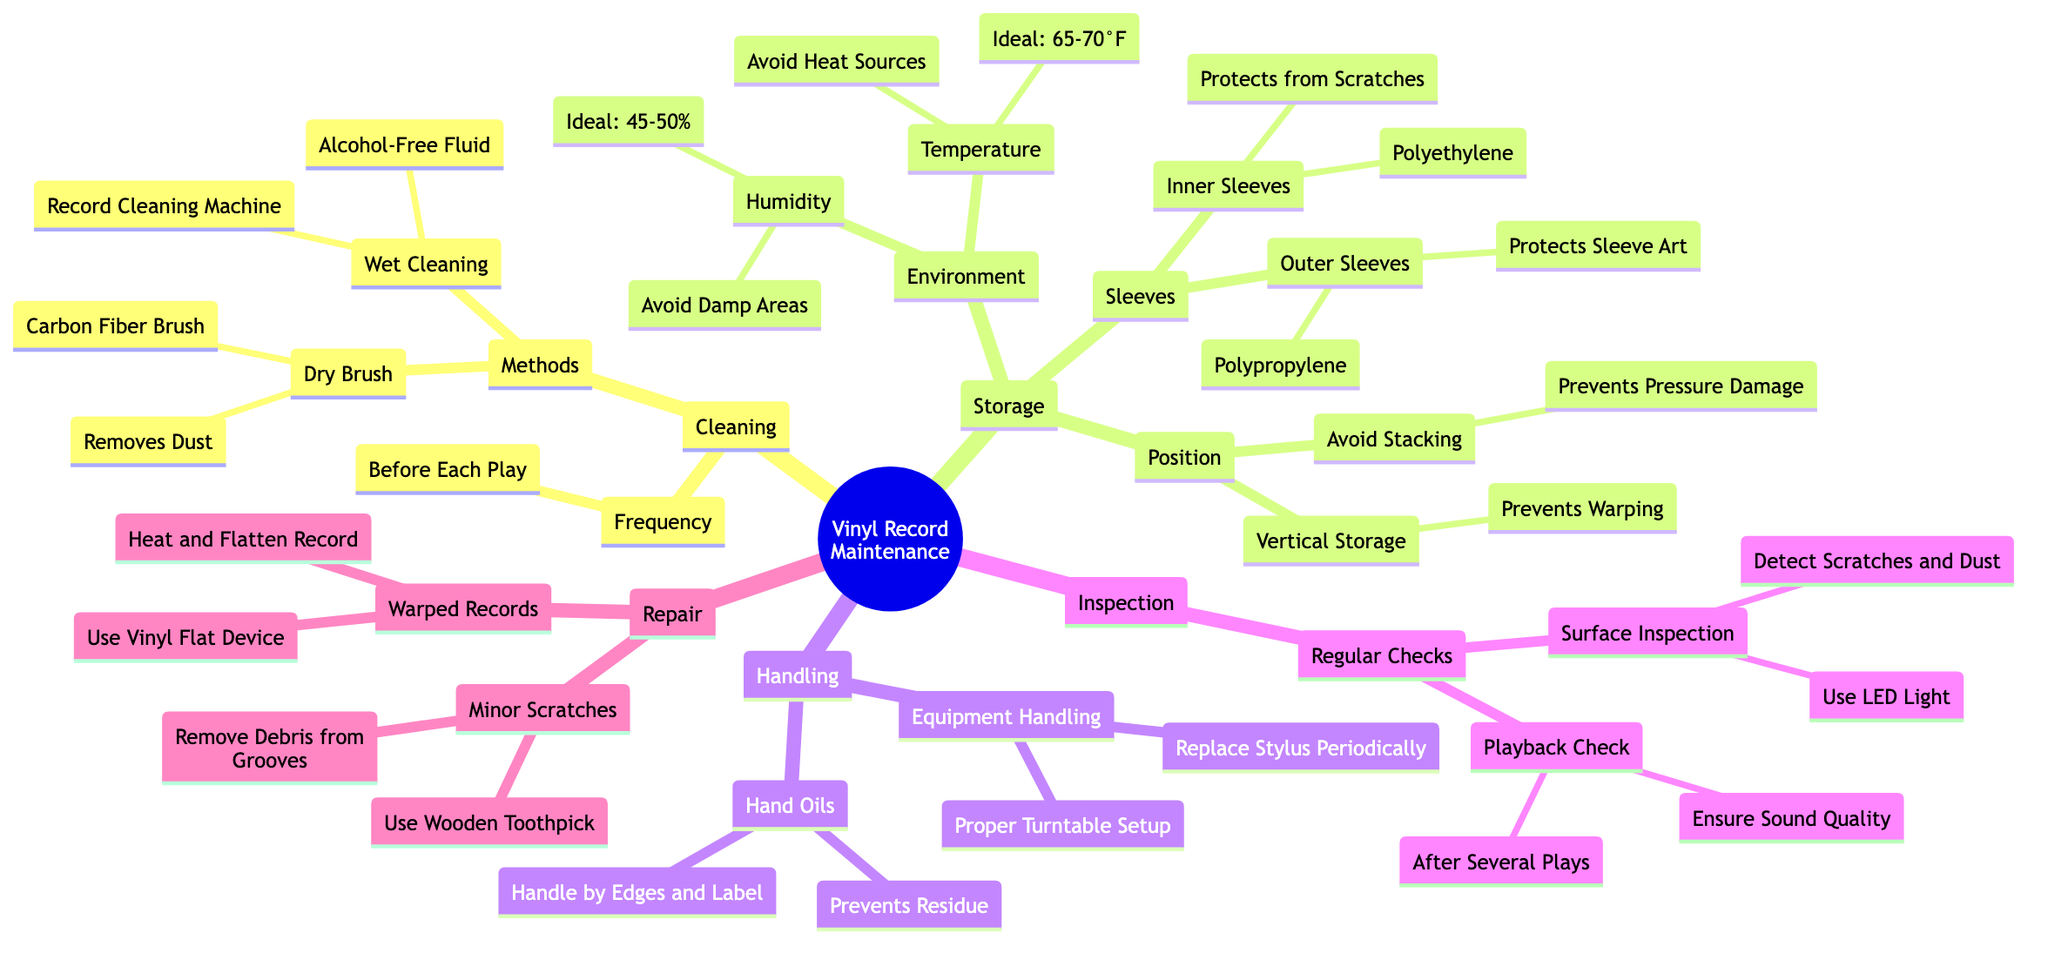What are the two methods for cleaning vinyl records? The diagram lists "Dry Brush" and "Wet Cleaning" under the "Methods" section in "Cleaning."
Answer: Dry Brush, Wet Cleaning What is the ideal temperature range for storing vinyl records? In the "Environment" section under "Storage," the ideal temperature is mentioned as "65-70°F."
Answer: 65-70°F What is the purpose of outer sleeves? In the "Sleeves" section under "Storage," it states that the purpose of outer sleeves is to "Protect Sleeve Art."
Answer: Protect Sleeve Art What should you avoid to prevent warping of vinyl records? The "Position" section under "Storage" indicates we should "Avoid Stacking" to prevent warping.
Answer: Avoid Stacking What is the reason for handling records by the edges and label? The "Hand Oils" section under "Handling" specifies that this method is used to "Prevent Residue."
Answer: Prevent Residue Why is it important to check playback after several plays? In the "Regular Checks" section under "Inspection," it notes that the purpose of playback checks is to "Ensure Sound Quality."
Answer: Ensure Sound Quality What tool is suggested for surface inspection of records? The "Surface Inspection" under "Regular Checks" states to use an "LED Light" for this purpose.
Answer: LED Light What should be used for minor scratches on vinyl records? The "Minor Scratches" section in "Repair" suggests using a "Wooden Toothpick."
Answer: Wooden Toothpick What is the humidity range to avoid for storing vinyl records? Under "Environment," the "Humidity" section states to avoid "Damp Areas," indicating that this humidity range should be managed.
Answer: Avoid Damp Areas 